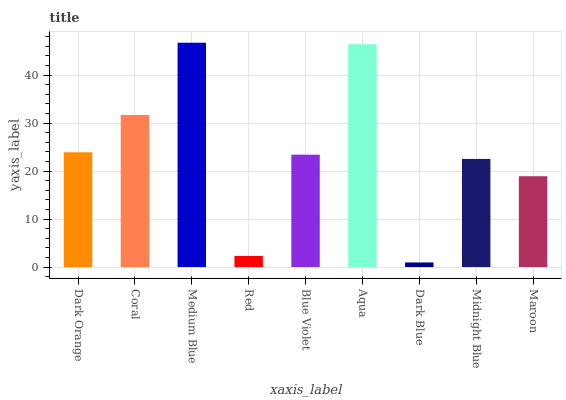Is Dark Blue the minimum?
Answer yes or no. Yes. Is Medium Blue the maximum?
Answer yes or no. Yes. Is Coral the minimum?
Answer yes or no. No. Is Coral the maximum?
Answer yes or no. No. Is Coral greater than Dark Orange?
Answer yes or no. Yes. Is Dark Orange less than Coral?
Answer yes or no. Yes. Is Dark Orange greater than Coral?
Answer yes or no. No. Is Coral less than Dark Orange?
Answer yes or no. No. Is Blue Violet the high median?
Answer yes or no. Yes. Is Blue Violet the low median?
Answer yes or no. Yes. Is Maroon the high median?
Answer yes or no. No. Is Medium Blue the low median?
Answer yes or no. No. 